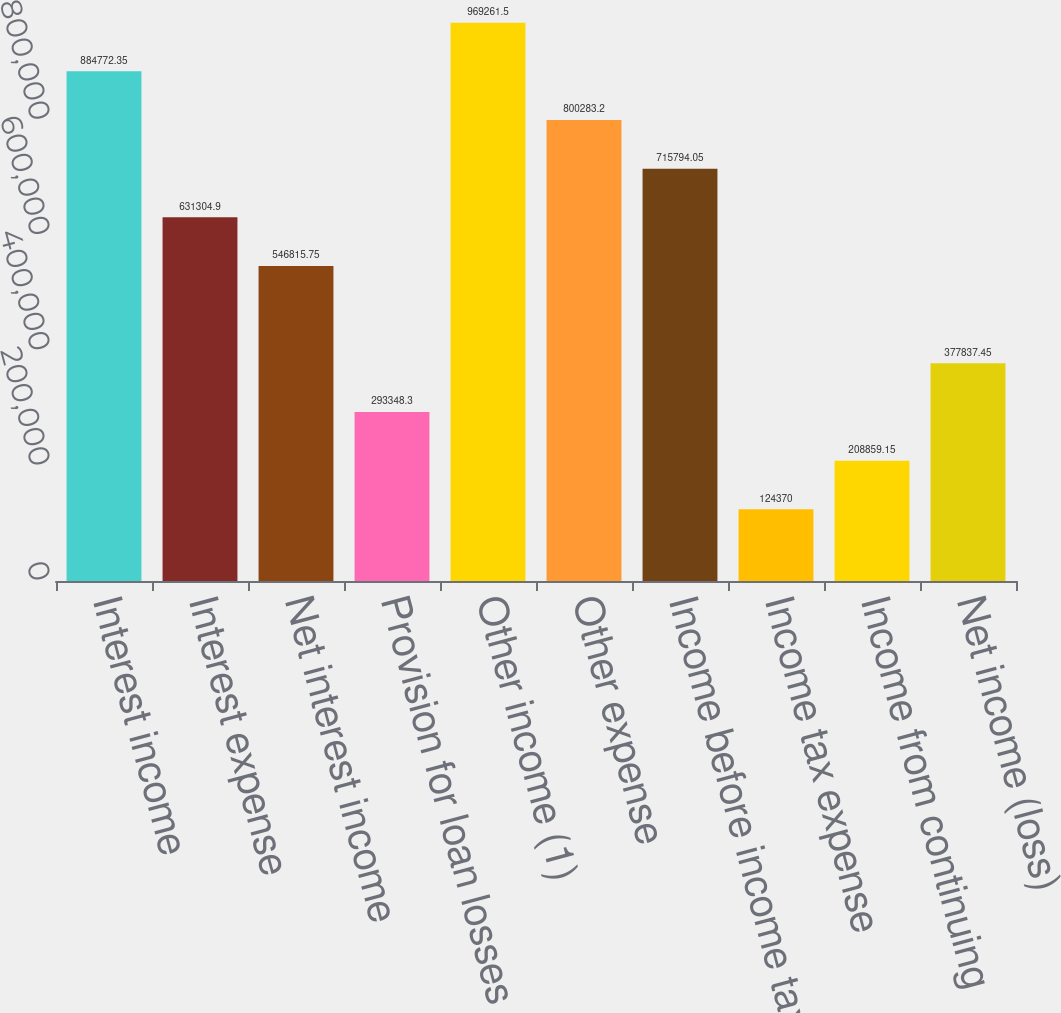Convert chart. <chart><loc_0><loc_0><loc_500><loc_500><bar_chart><fcel>Interest income<fcel>Interest expense<fcel>Net interest income<fcel>Provision for loan losses<fcel>Other income (1)<fcel>Other expense<fcel>Income before income tax<fcel>Income tax expense<fcel>Income from continuing<fcel>Net income (loss)<nl><fcel>884772<fcel>631305<fcel>546816<fcel>293348<fcel>969262<fcel>800283<fcel>715794<fcel>124370<fcel>208859<fcel>377837<nl></chart> 